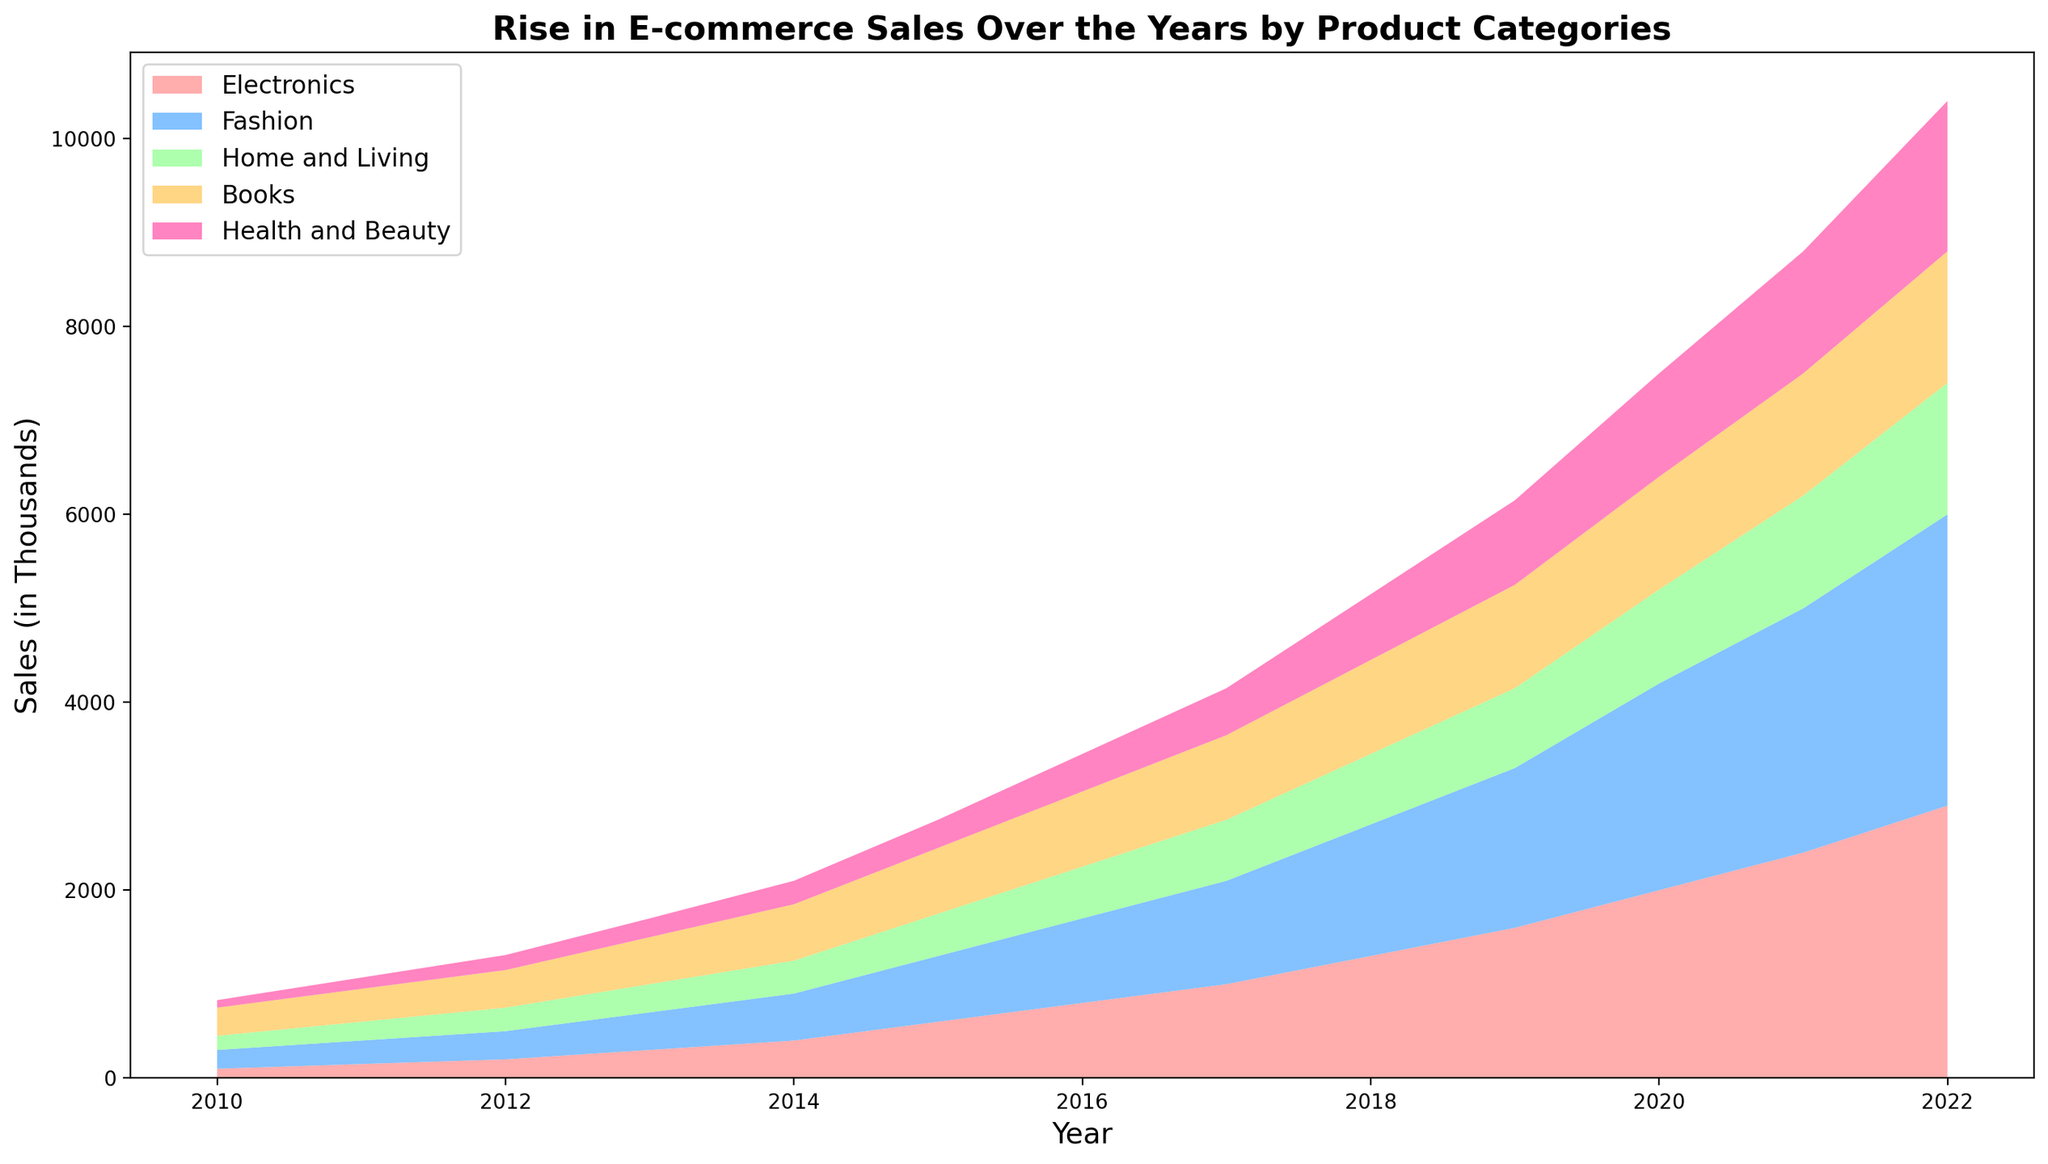What was the total e-commerce sales in 2020? To find the total e-commerce sales in 2020, sum the sales of all product categories for the year 2020: Electronics (2000), Fashion (2200), Home and Living (1000), Books (1200), Health and Beauty (1100). Therefore, 2000 + 2200 + 1000 + 1200 + 1100 = 7500.
Answer: 7500 Which product category saw the highest growth in sales from 2010 to 2022? Look at the difference in sales from 2010 to 2022 for each category: Electronics (2900-100=2800), Fashion (3100-200=2900), Home and Living (1400-150=1250), Books (1400-300=1100), Health and Beauty (1600-80=1520). Fashion had the highest growth.
Answer: Fashion In which year did Home and Living sales surpass 500 thousand? Observe the sales of Home and Living over the years. Home and Living sales surpassed 500 thousand in 2016 with 550.
Answer: 2016 How do the sales of Books in 2022 compare to those in 2015? Compare the sales figures for Books in 2022 and 2015. Books had 1400 in 2022 and 700 in 2015. 1400 - 700 = 700 more units in 2022.
Answer: 700 more in 2022 What is the difference between Fashion and Electronics sales in 2021? The sales for Fashion and Electronics in 2021 are 2600 and 2400 respectively. The difference is 2600 - 2400 = 200.
Answer: 200 What year saw the highest sales for Health and Beauty? Check the sales for Health and Beauty each year. The highest sales were in 2022, which were 1600.
Answer: 2022 How does the growth in Electronics compare to that in Books from 2010 to 2022? Calculate the growth for both categories: Electronics grew from 100 to 2900 (2800 increase) and Books grew from 300 to 1400 (1100 increase). Electronics grew more.
Answer: Electronics grew more Which year had the smallest increase in total sales compared to the previous year? Evaluate the increase in total sales for each year compared to the previous year: the smallest increase is from 2014 (2100) to 2015 (2750), which is an increase of 650.
Answer: 2014 to 2015 Are Fashion sales consistently higher than Books sales over the years? Compare the Fashion and Books sales figures for each year. Fashion sales are consistently higher in all years.
Answer: Yes What is the average yearly increase in Health and Beauty sales from 2010 to 2022? Find the sales difference from 2010 to 2022 (1600 - 80 = 1520) and then divide by the number of years (2022 - 2010 = 12). Thus, 1520 / 12 ≈ 126.7.
Answer: ~126.7 